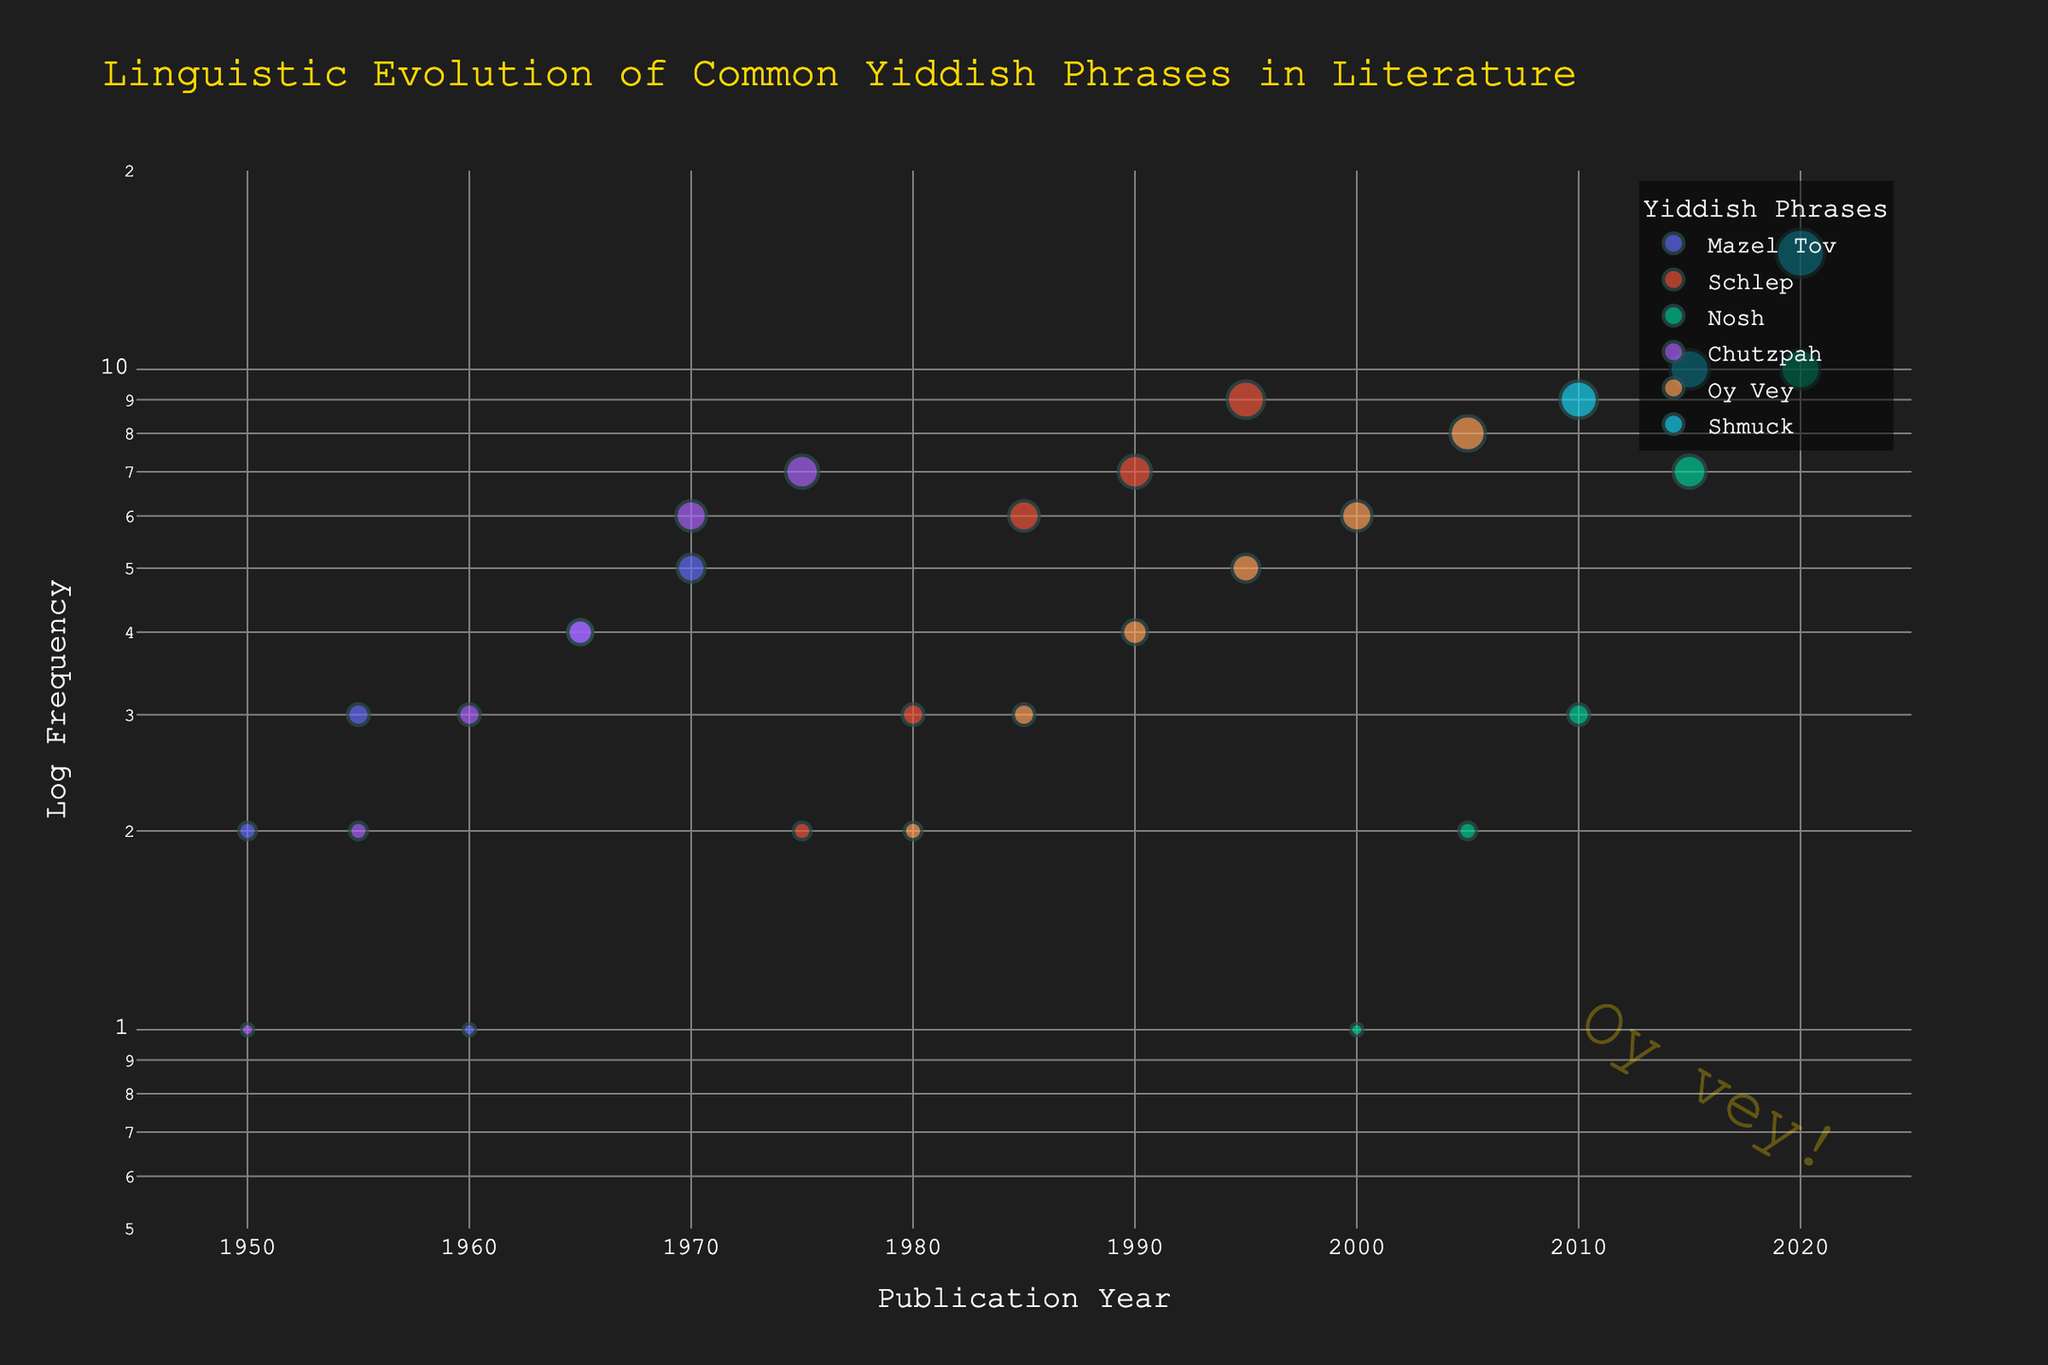What is the plot's title? The title of the plot is displayed at the top and is in larger, gold-colored font. This element summarizes the central theme of the visualized data.
Answer: Linguistic Evolution of Common Yiddish Phrases in Literature Which phrase has the highest frequency in 2020? Observing the x-axis for 2020 and checking the corresponding data point with the highest y-value. The phrase with the largest marker size and highest y-value for 2020 is the answer.
Answer: Shmuck In which year did "Nosh" surpass a frequency of 5? Look for the data points for "Nosh" on the plot. Noticing the change in marker size and position on the y-axis, the year when the frequency first exceeds or equals 5 is noted.
Answer: 2015 How does the trend in the frequency of "Schlep" compare between 1950 and 1995? Trace the data points for "Schlep" from 1950 to 1995 and examine the pattern. Starting with the initial frequency in 1950, see the increase or decrease in subsequent years, particularly noting the difference until 1995.
Answer: It increases Which phrase showed a steady increase in frequency from 1950 to 1975? Identify the phrases with continuous data points from 1950 to 1975. Compare the trend (and marker size change) across these years to see which phrase shows a consistent rise without drops.
Answer: Chutzpah What is the frequency of "Oy Vey" in 2005? Find the data point for "Oy Vey" on the x-axis at 2005 and read the corresponding y-value.
Answer: 8 Which phrase had the largest increase in frequency from 2010 to 2020? Compare the frequency values for all phrases between 2010 and 2020. Calculate the difference for each phrase by subtracting the 2010 value from the 2020 value, identifying the largest increase.
Answer: Shmuck How many phrases have data points plotted from 1950 to 1965? Count the unique phrases with markers (data points) at each of the years 1950, 1955, 1960, and 1965.
Answer: 2 (Mazel Tov and Chutzpah) Which years have the same frequency value for "Chutzpah" and "Oy Vey"? Compare the data points for "Chutzpah" and "Oy Vey" across the years, checking for any instances where the y-values (frequencies) are equal.
Answer: 1980 What is the log scale range used for the y-axis? Read the plot's y-axis details which denote the logarithmic scales applied. The minimum and maximum values are identified as the log scale range.
Answer: 0.5 to 20 